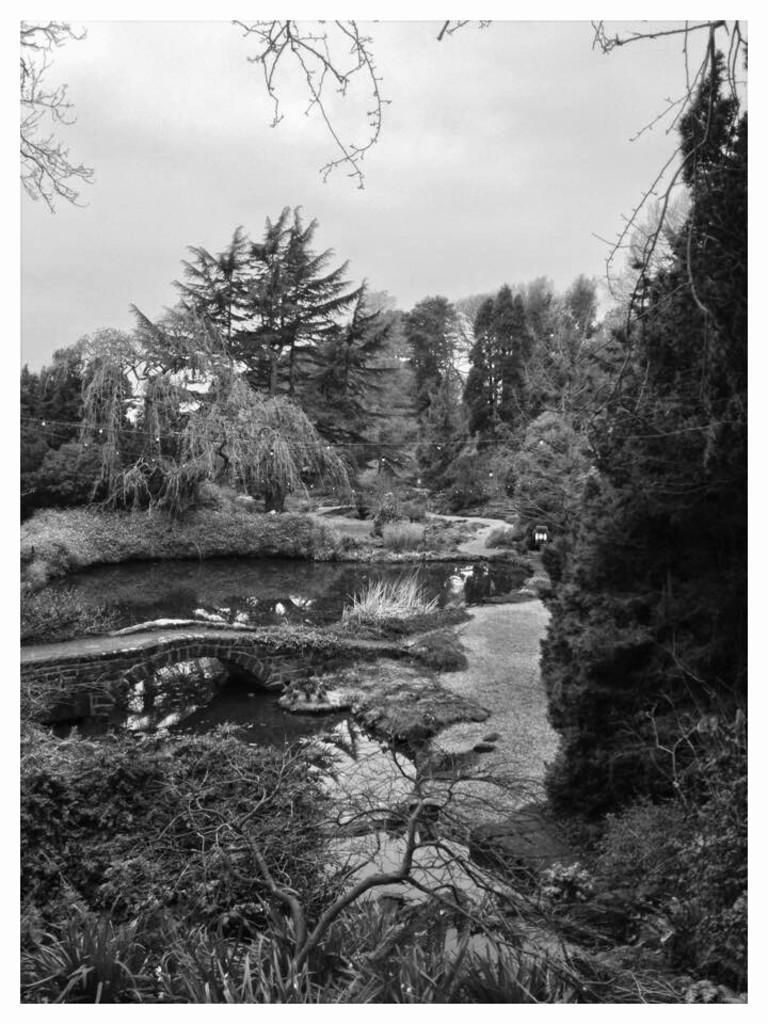How would you summarize this image in a sentence or two? This is a black and white picture where I can see trees, stone bridge, water and the sky in the background. 